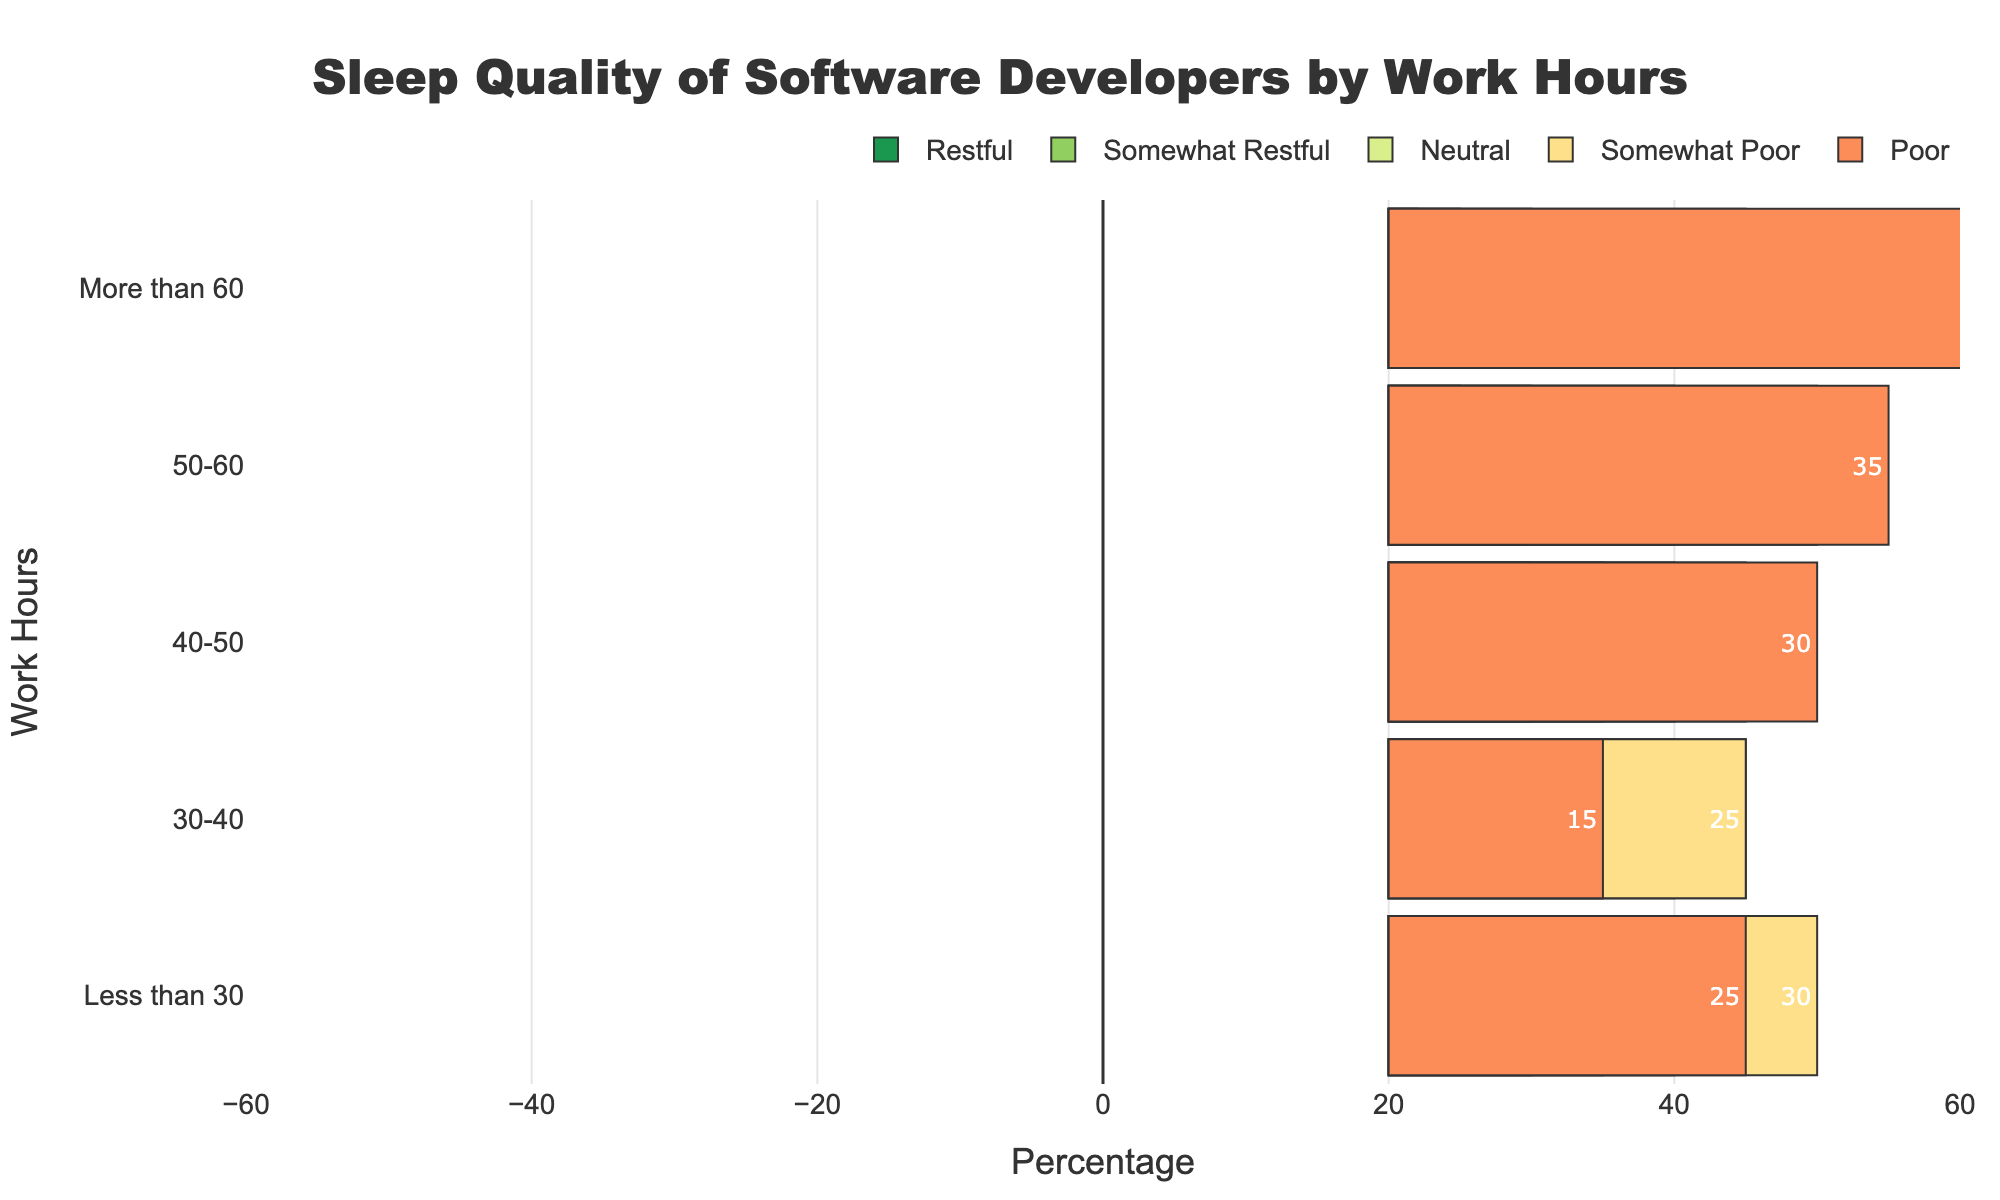What's the percentage of developers working more than 60 hours who report poor sleep quality? Look at the "More than 60" bar and find the segment labeled "Poor." The text inside the bar segment shows the percentage.
Answer: 58% Which work hour category has the highest percentage of developers reporting restful sleep? Compare the "Restful" segments across all work hour categories. The "30-40" category has the highest value in the "Restful" segment.
Answer: 30-40 Compare the percentage of developers who report neutral sleep quality for the "30-40" hour category and the "40-50" hour category. Locate the "Neutral" segments for the "30-40" and "40-50" categories. The numbers inside the bars indicate the percentage for each.
Answer: 25 for both In which work hour category is the difference between the percentage of developers reporting somewhat poor and poor sleep quality the smallest? For each category, subtract the percentage of somewhat poor sleep from the poor sleep quality. The smallest difference is in the "50-60" category (difference = 35 - 30 = 5).
Answer: 50-60 How does the percentage of developers reporting somewhat restful sleep change as work hours increase from 40-50 to 50-60? Compare the "Somewhat Restful" segments for "40-50" and "50-60." The percentages show a decrease from 15% to 10%.
Answer: Decreases What is the average percentage of developers reporting restful sleep across all work hour categories? Sum the percentages of developers reporting restful sleep across all categories (10 + 15 + 10 + 5 + 2 = 42), then divide by the number of categories (5). The average percentage is 42/5 = 8.4%.
Answer: 8.4% What color represents the "Somewhat Poor" sleep quality in the chart? Identify the bar segment labeled "Somewhat Poor." The visual attribute (color) of this segment can be observed.
Answer: Yellow 